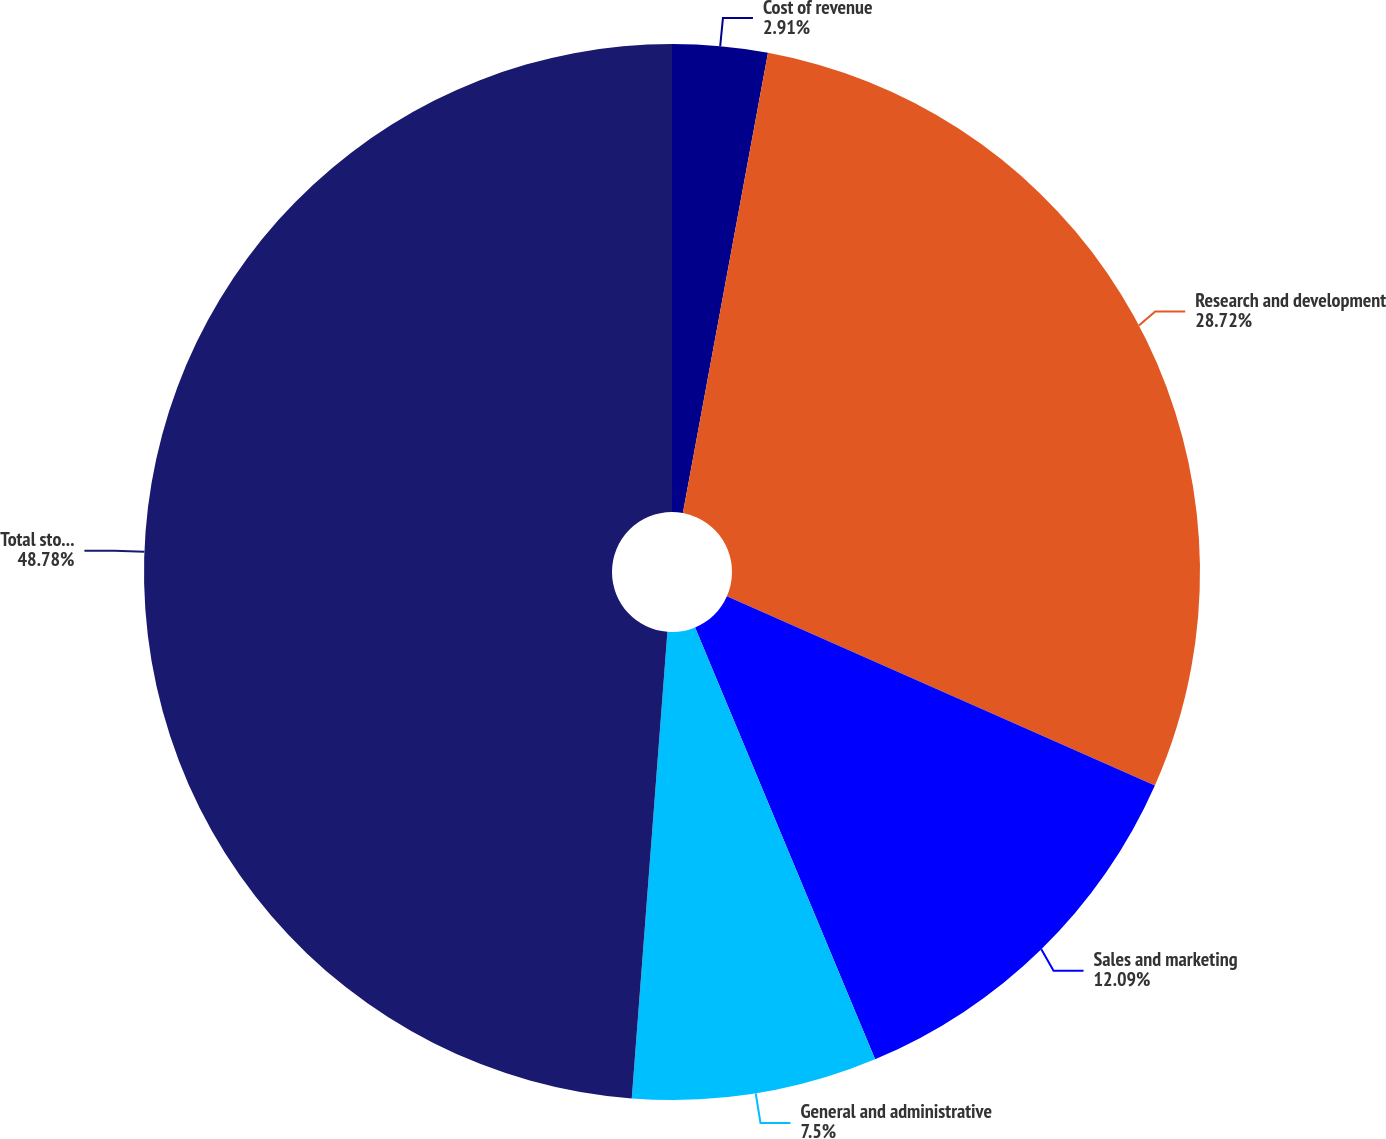Convert chart. <chart><loc_0><loc_0><loc_500><loc_500><pie_chart><fcel>Cost of revenue<fcel>Research and development<fcel>Sales and marketing<fcel>General and administrative<fcel>Total stock-based compensation<nl><fcel>2.91%<fcel>28.72%<fcel>12.09%<fcel>7.5%<fcel>48.79%<nl></chart> 